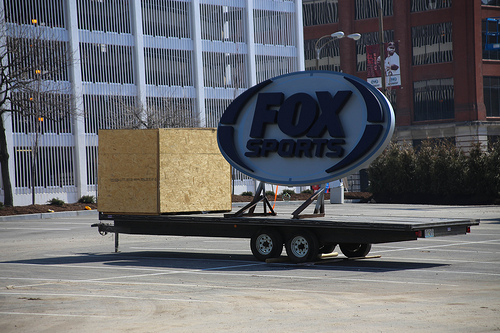<image>
Can you confirm if the box is on the ground? No. The box is not positioned on the ground. They may be near each other, but the box is not supported by or resting on top of the ground. 